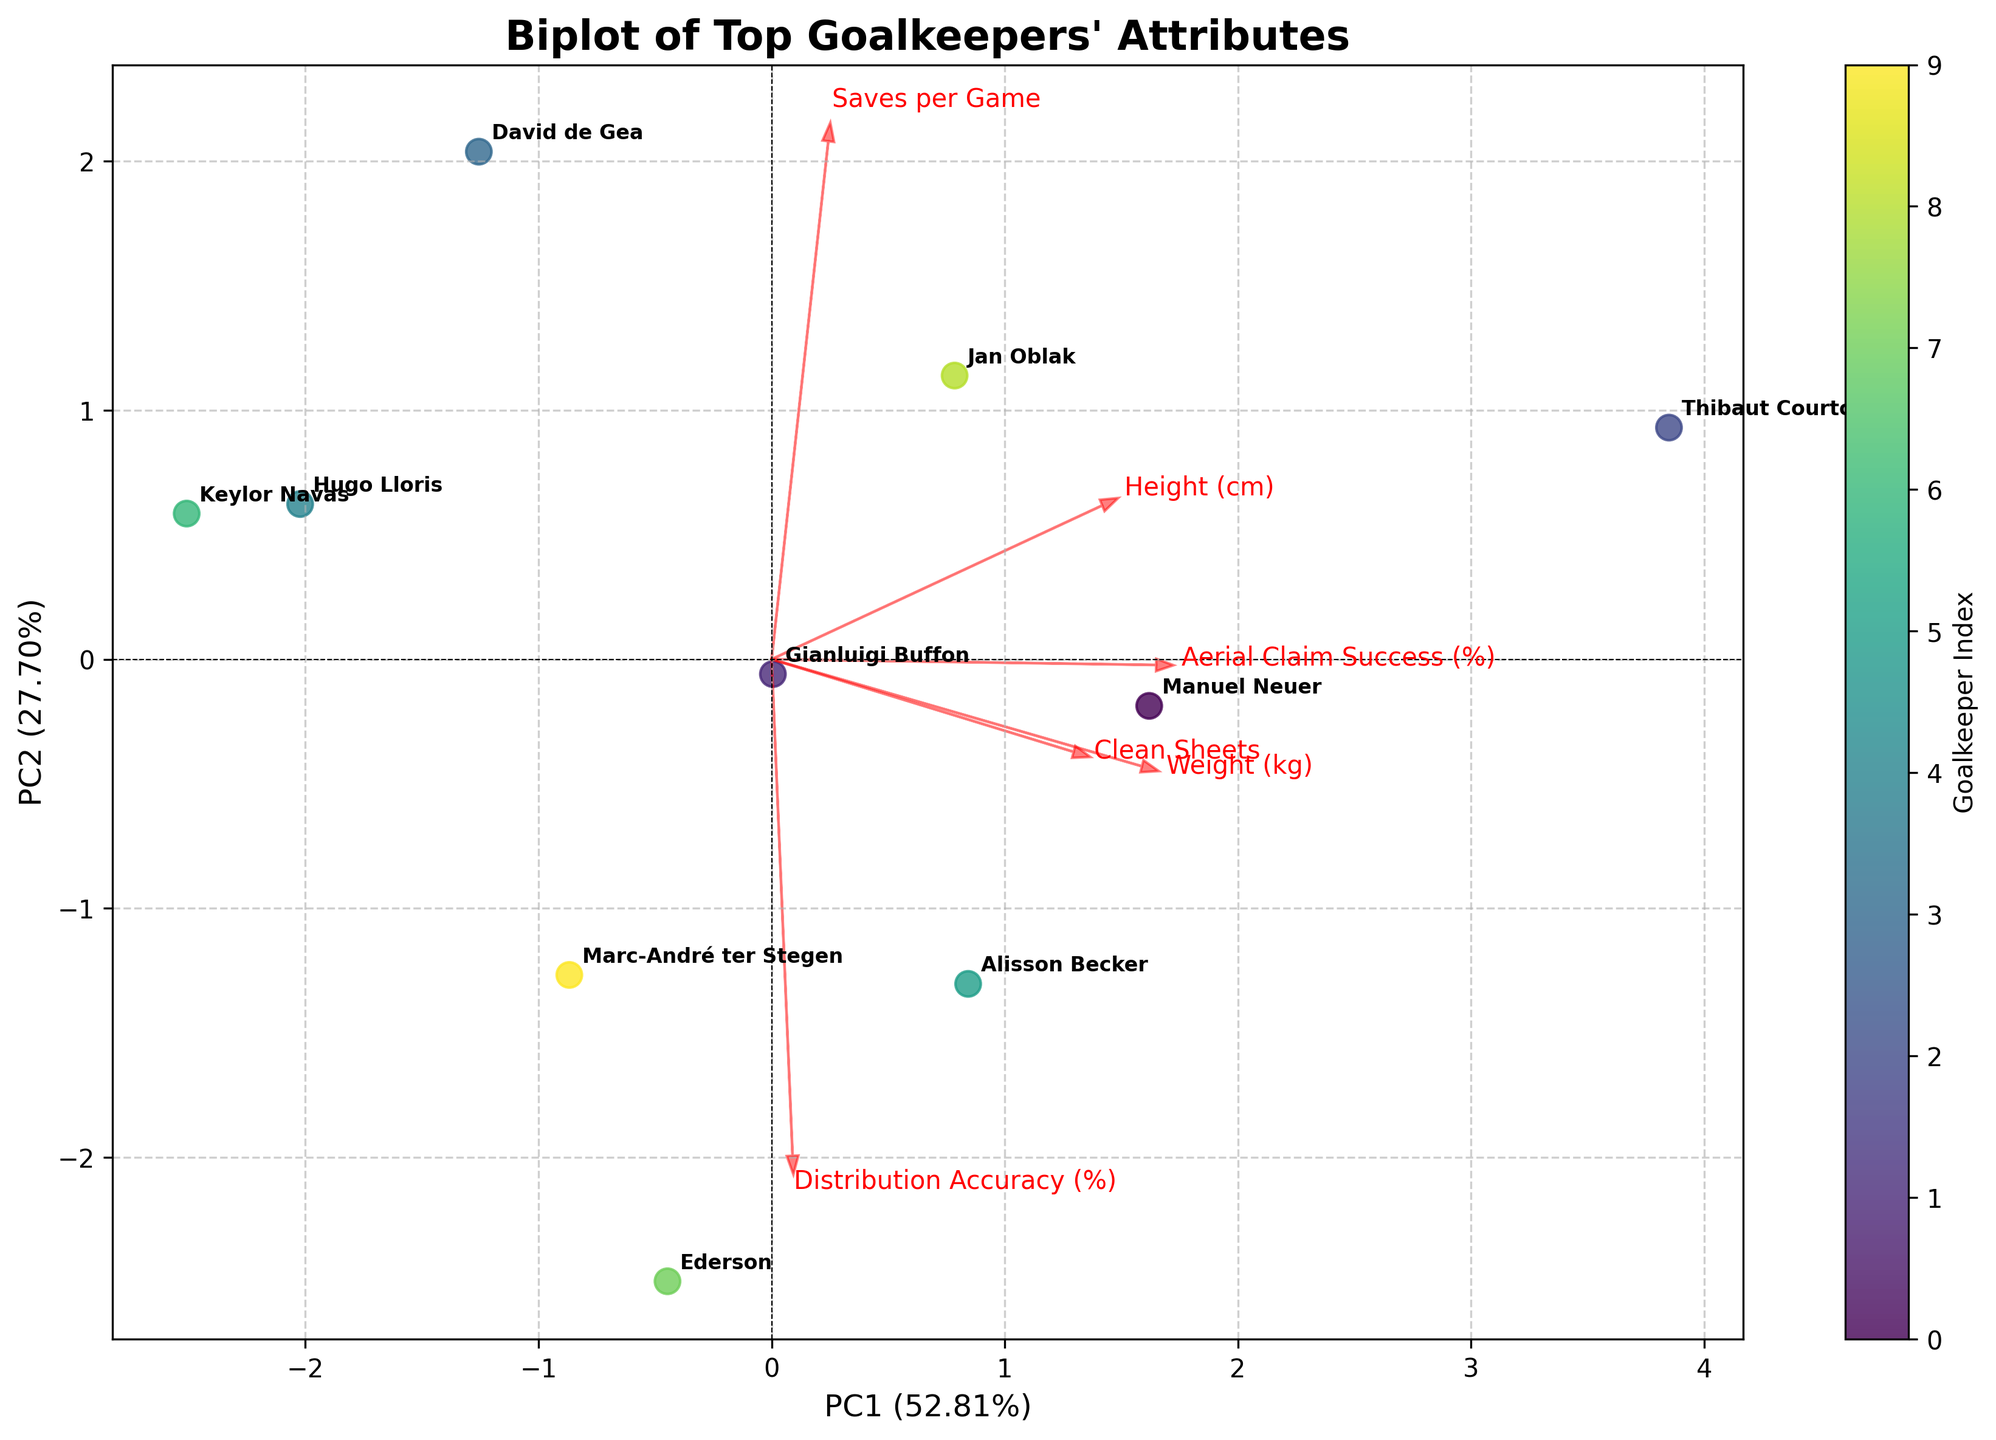How many goalkeepers are represented in the plot? Count the number of goalkeeper labels displayed in the biplot. Each label corresponds to one goalkeeper.
Answer: 10 What is the approximate title of the biplot? Look for the title at the top of the biplot to see the full title or keyword phrases indicative of the plot's focus.
Answer: Biplot of Top Goalkeepers' Attributes Which goalkeeper is most closely associated with high 'Distribution Accuracy (%)'? Observe the direction and length of the arrow labeled 'Distribution Accuracy (%)'. Identify which goalkeeper's label is closest to the tip of this arrow.
Answer: Ederson Which attributes have vectors closely aligned and likely correlate strongly? Look for attribute vectors that are parallel or nearly parallel, indicating a strong linear relationship between these attributes.
Answer: Height (cm) and Weight (kg) Who has the highest 'Aerial Claim Success (%)'? Identify the direction of the arrow for 'Aerial Claim Success (%)' and find the goalkeeper closest to the tip of this arrow.
Answer: Thibaut Courtois What proportion of the total variance is explained by the first Principal Component (PC1)? Check the x-axis label, which usually includes the percentage variance explained by PC1.
Answer: Approximately 55% Draw a comparison between David de Gea and Keylor Navas based on their PC1 and PC2 scores. Locate the labels for David de Gea and Keylor Navas. Compare their positions along both the x-axis (PC1) and y-axis (PC2).
Answer: David de Gea has a lower PC1 score and a higher PC2 score than Keylor Navas Which feature contributes most to PC2 based on the length and direction of the vectors? Find the feature whose arrow along the y-axis (PC2) is largest when considering the direction and length.
Answer: Aerial Claim Success (%) If we consider 'Saves per Game' and 'Clean Sheets', which goalkeeper stands out the most positively in these attributes? Identify the direction of the arrows for 'Saves per Game' and 'Clean Sheets', and find which goalkeeper's label is close to the tips of these arrows.
Answer: Thibaut Courtois How much of the total variance is explained by the combined first two Principal Components (PC1 and PC2)? Sum the percentages indicated on each axis: PC1 and PC2, usually found in parentheses.
Answer: Approximately 90% 